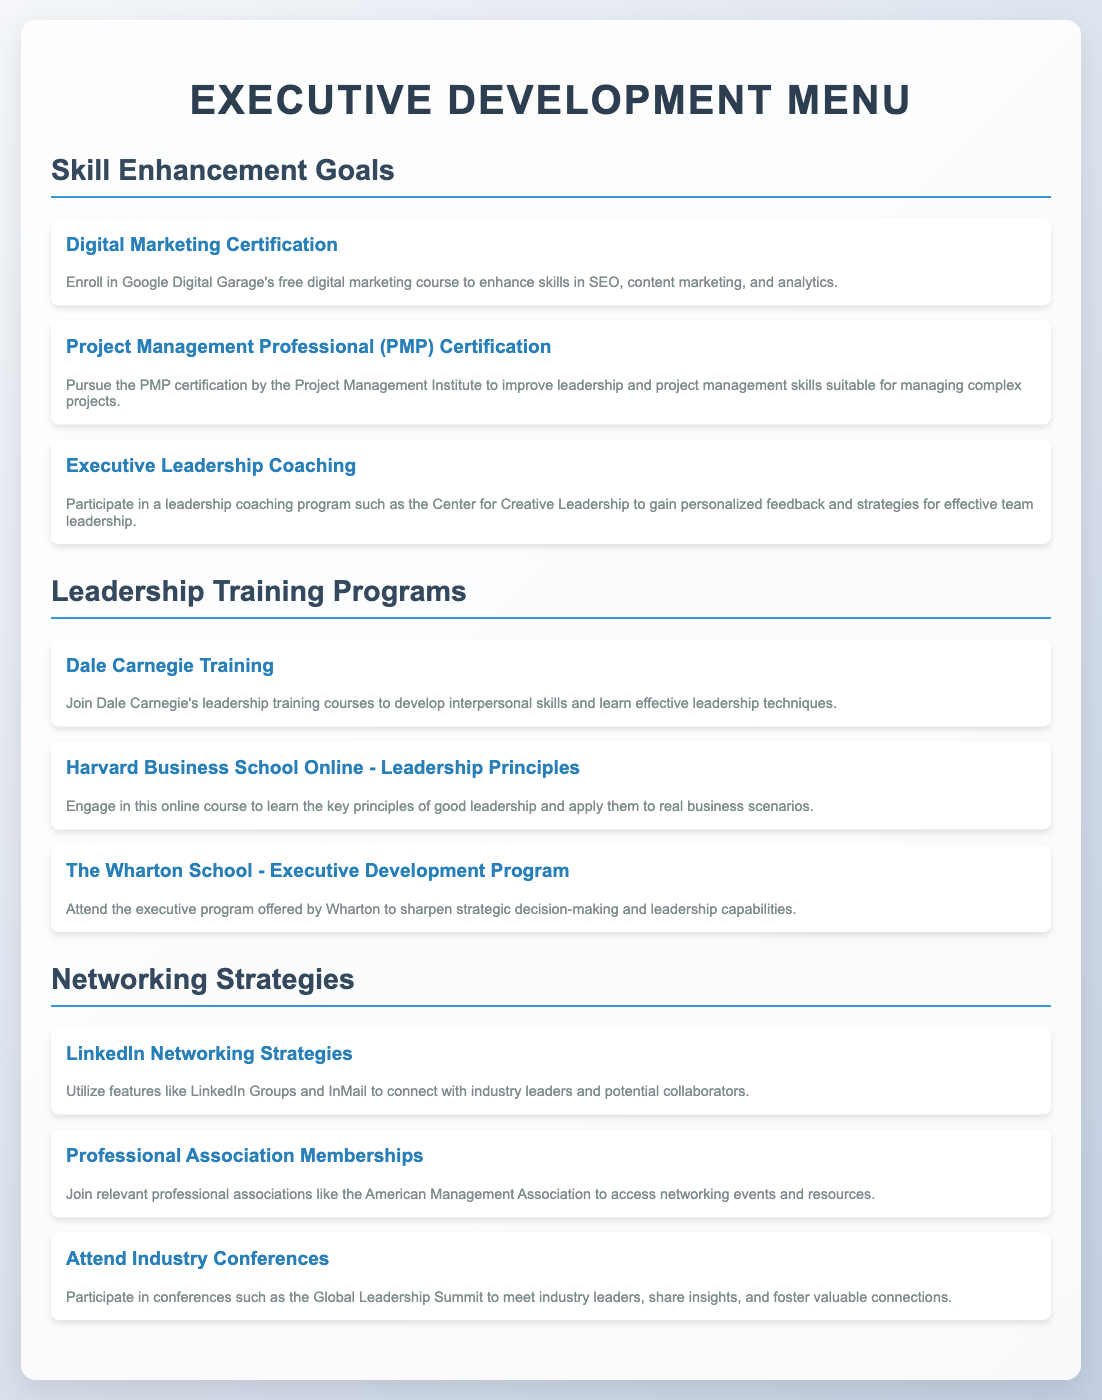what is the title of the document? The title of the document is displayed prominently at the top of the webpage within an <h1> tag.
Answer: Executive Development Menu how many skill enhancement goals are listed? The number of skill enhancement goals can be determined by counting the menu items in that section.
Answer: 3 what certification focuses on project management? This certification is specifically aimed at improving project management skills as noted in the description for one of the menu items.
Answer: Project Management Professional (PMP) Certification what training program is associated with Harvard Business School? The training program associated with Harvard Business School is mentioned in a menu item about leadership principles.
Answer: Harvard Business School Online - Leadership Principles which organization offers a leadership coaching program? This question requires identifying the organization responsible for the mentioned leadership coaching program within the menu.
Answer: Center for Creative Leadership how many networking strategies are mentioned? To answer this, one should count the different strategies listed under the networking section of the document.
Answer: 3 what is the purpose of attending industry conferences? The purpose is derived from the description of the relevant menu item in the networking strategies section.
Answer: Meet industry leaders which item includes learning about digital marketing? This question pertains to identifying the specific course that focuses on digital marketing within the skill enhancement goals.
Answer: Digital Marketing Certification what is one benefit of joining professional associations? This benefit can be inferred from the description provided under the relevant networking strategy.
Answer: Access networking events 